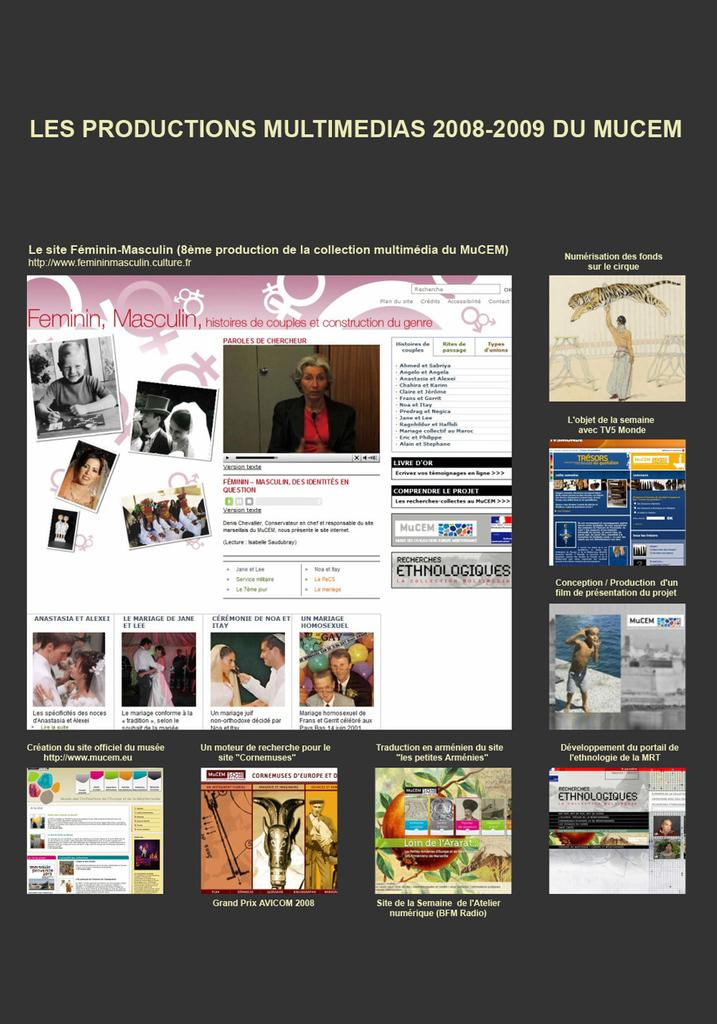What type of artwork is depicted in the image? The image is a collage. What elements are included in the collage? There are pictures and text in the collage. What type of food is being served in the collage? There is no food present in the collage; it only contains pictures and text. 